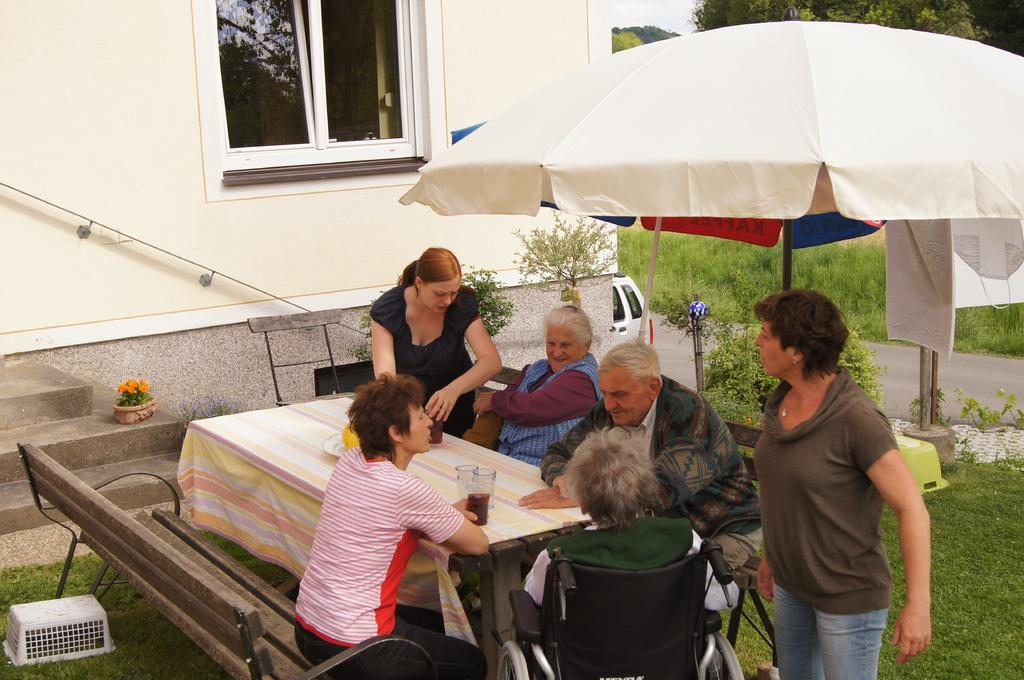What are the people in the image doing? There is a group of people sitting near a table in the image. What can be seen in the background of the image? In the background, there is a car, an umbrella, a plant, grass, a building, a tree, and the sky. How many people are sitting near the table? The number of people sitting near the table is not specified in the facts, so it cannot be determined. What type of bean is being served to the crowd in the image? There is no crowd or bean present in the image; it features a group of people sitting near a table. Is the image taken during a rainstorm? The image does not show any signs of a rainstorm, and the sky is visible in the background, which suggests clear weather. 